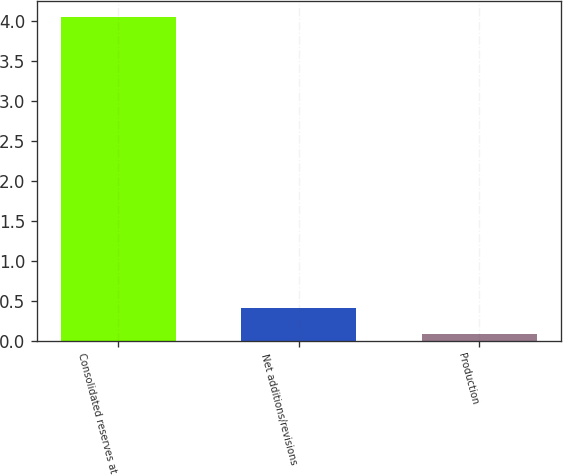Convert chart to OTSL. <chart><loc_0><loc_0><loc_500><loc_500><bar_chart><fcel>Consolidated reserves at<fcel>Net additions/revisions<fcel>Production<nl><fcel>4.05<fcel>0.41<fcel>0.08<nl></chart> 